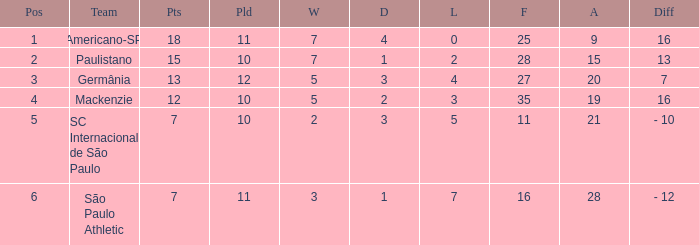Name the most for when difference is 7 27.0. 